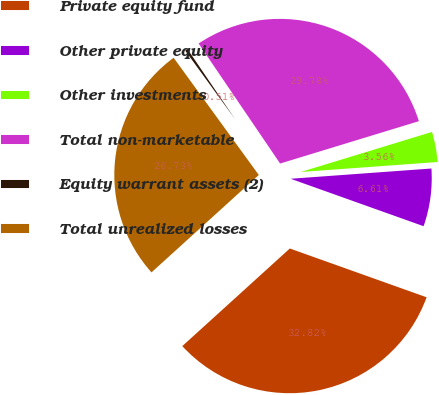Convert chart to OTSL. <chart><loc_0><loc_0><loc_500><loc_500><pie_chart><fcel>Private equity fund<fcel>Other private equity<fcel>Other investments<fcel>Total non-marketable<fcel>Equity warrant assets (2)<fcel>Total unrealized losses<nl><fcel>32.82%<fcel>6.61%<fcel>3.56%<fcel>29.78%<fcel>0.51%<fcel>26.73%<nl></chart> 